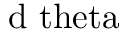<formula> <loc_0><loc_0><loc_500><loc_500>d \ t h e t a</formula> 